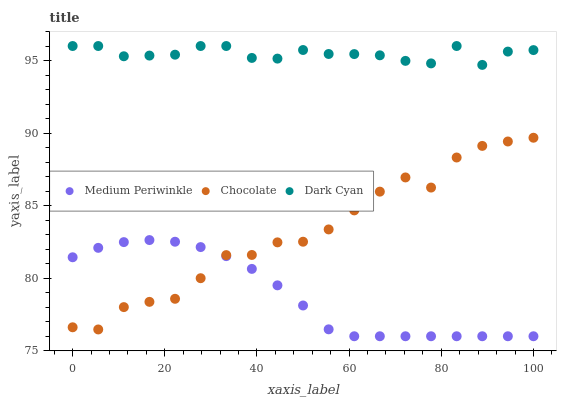Does Medium Periwinkle have the minimum area under the curve?
Answer yes or no. Yes. Does Dark Cyan have the maximum area under the curve?
Answer yes or no. Yes. Does Chocolate have the minimum area under the curve?
Answer yes or no. No. Does Chocolate have the maximum area under the curve?
Answer yes or no. No. Is Medium Periwinkle the smoothest?
Answer yes or no. Yes. Is Chocolate the roughest?
Answer yes or no. Yes. Is Chocolate the smoothest?
Answer yes or no. No. Is Medium Periwinkle the roughest?
Answer yes or no. No. Does Medium Periwinkle have the lowest value?
Answer yes or no. Yes. Does Chocolate have the lowest value?
Answer yes or no. No. Does Dark Cyan have the highest value?
Answer yes or no. Yes. Does Chocolate have the highest value?
Answer yes or no. No. Is Chocolate less than Dark Cyan?
Answer yes or no. Yes. Is Dark Cyan greater than Medium Periwinkle?
Answer yes or no. Yes. Does Medium Periwinkle intersect Chocolate?
Answer yes or no. Yes. Is Medium Periwinkle less than Chocolate?
Answer yes or no. No. Is Medium Periwinkle greater than Chocolate?
Answer yes or no. No. Does Chocolate intersect Dark Cyan?
Answer yes or no. No. 